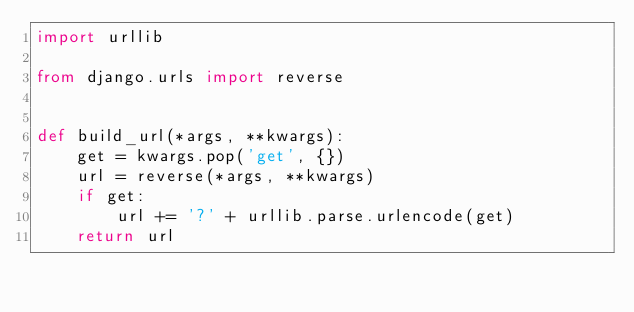Convert code to text. <code><loc_0><loc_0><loc_500><loc_500><_Python_>import urllib

from django.urls import reverse


def build_url(*args, **kwargs):
    get = kwargs.pop('get', {})
    url = reverse(*args, **kwargs)
    if get:
        url += '?' + urllib.parse.urlencode(get)
    return url
</code> 